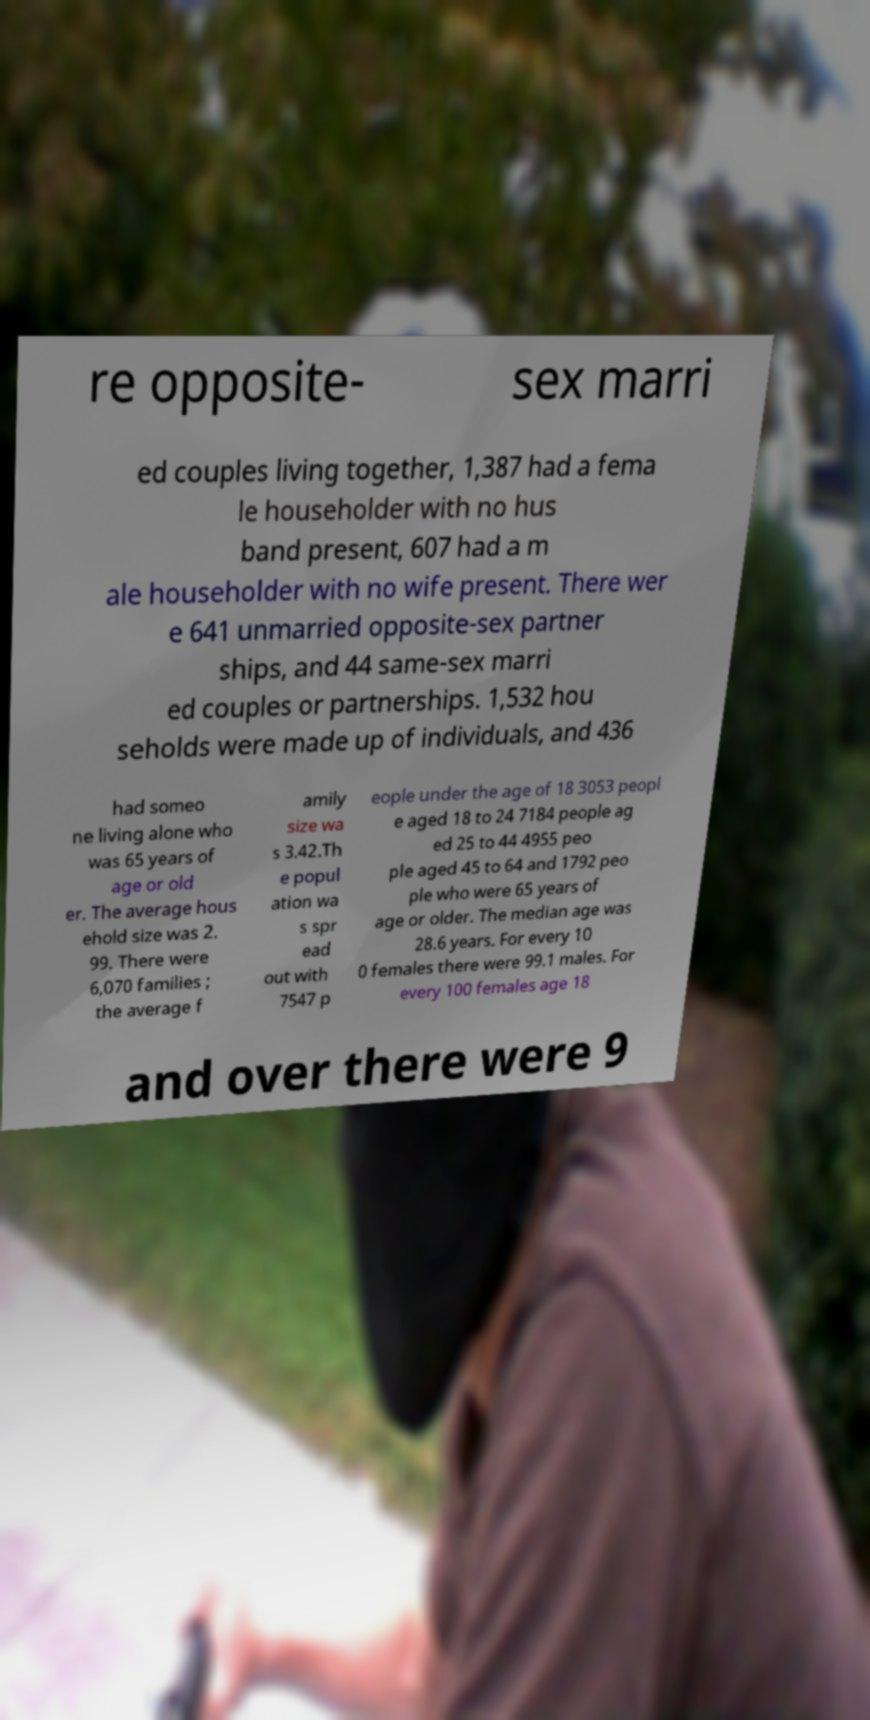Can you accurately transcribe the text from the provided image for me? re opposite- sex marri ed couples living together, 1,387 had a fema le householder with no hus band present, 607 had a m ale householder with no wife present. There wer e 641 unmarried opposite-sex partner ships, and 44 same-sex marri ed couples or partnerships. 1,532 hou seholds were made up of individuals, and 436 had someo ne living alone who was 65 years of age or old er. The average hous ehold size was 2. 99. There were 6,070 families ; the average f amily size wa s 3.42.Th e popul ation wa s spr ead out with 7547 p eople under the age of 18 3053 peopl e aged 18 to 24 7184 people ag ed 25 to 44 4955 peo ple aged 45 to 64 and 1792 peo ple who were 65 years of age or older. The median age was 28.6 years. For every 10 0 females there were 99.1 males. For every 100 females age 18 and over there were 9 